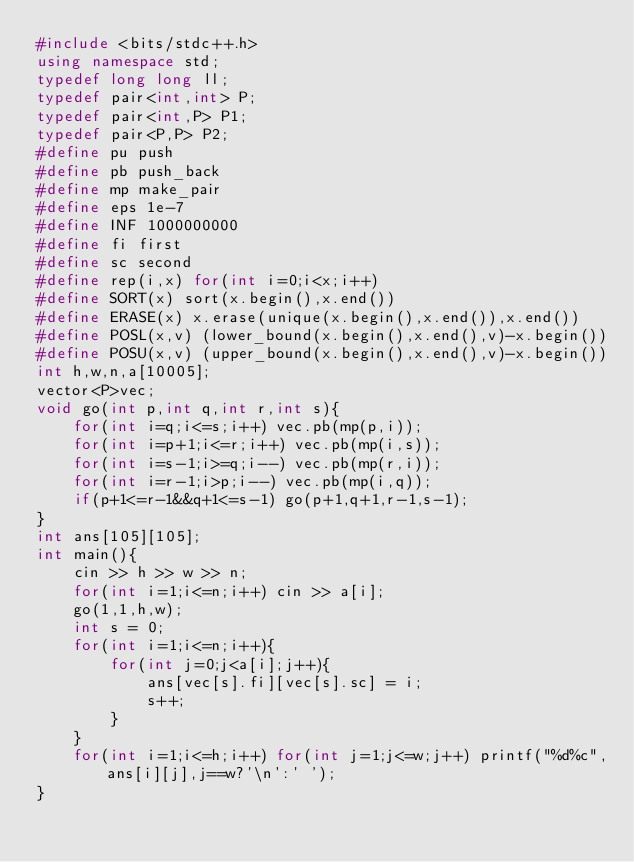<code> <loc_0><loc_0><loc_500><loc_500><_C++_>#include <bits/stdc++.h>
using namespace std;
typedef long long ll;
typedef pair<int,int> P;
typedef pair<int,P> P1;
typedef pair<P,P> P2;
#define pu push
#define pb push_back
#define mp make_pair
#define eps 1e-7
#define INF 1000000000
#define fi first
#define sc second
#define rep(i,x) for(int i=0;i<x;i++)
#define SORT(x) sort(x.begin(),x.end())
#define ERASE(x) x.erase(unique(x.begin(),x.end()),x.end())
#define POSL(x,v) (lower_bound(x.begin(),x.end(),v)-x.begin())
#define POSU(x,v) (upper_bound(x.begin(),x.end(),v)-x.begin())
int h,w,n,a[10005];
vector<P>vec;
void go(int p,int q,int r,int s){
	for(int i=q;i<=s;i++) vec.pb(mp(p,i));
	for(int i=p+1;i<=r;i++) vec.pb(mp(i,s));
	for(int i=s-1;i>=q;i--) vec.pb(mp(r,i));
	for(int i=r-1;i>p;i--) vec.pb(mp(i,q));
	if(p+1<=r-1&&q+1<=s-1) go(p+1,q+1,r-1,s-1);
}
int ans[105][105];
int main(){
	cin >> h >> w >> n;
	for(int i=1;i<=n;i++) cin >> a[i];
	go(1,1,h,w);
	int s = 0;
	for(int i=1;i<=n;i++){
		for(int j=0;j<a[i];j++){
			ans[vec[s].fi][vec[s].sc] = i;
			s++;
		}
	}
	for(int i=1;i<=h;i++) for(int j=1;j<=w;j++) printf("%d%c",ans[i][j],j==w?'\n':' ');
}</code> 